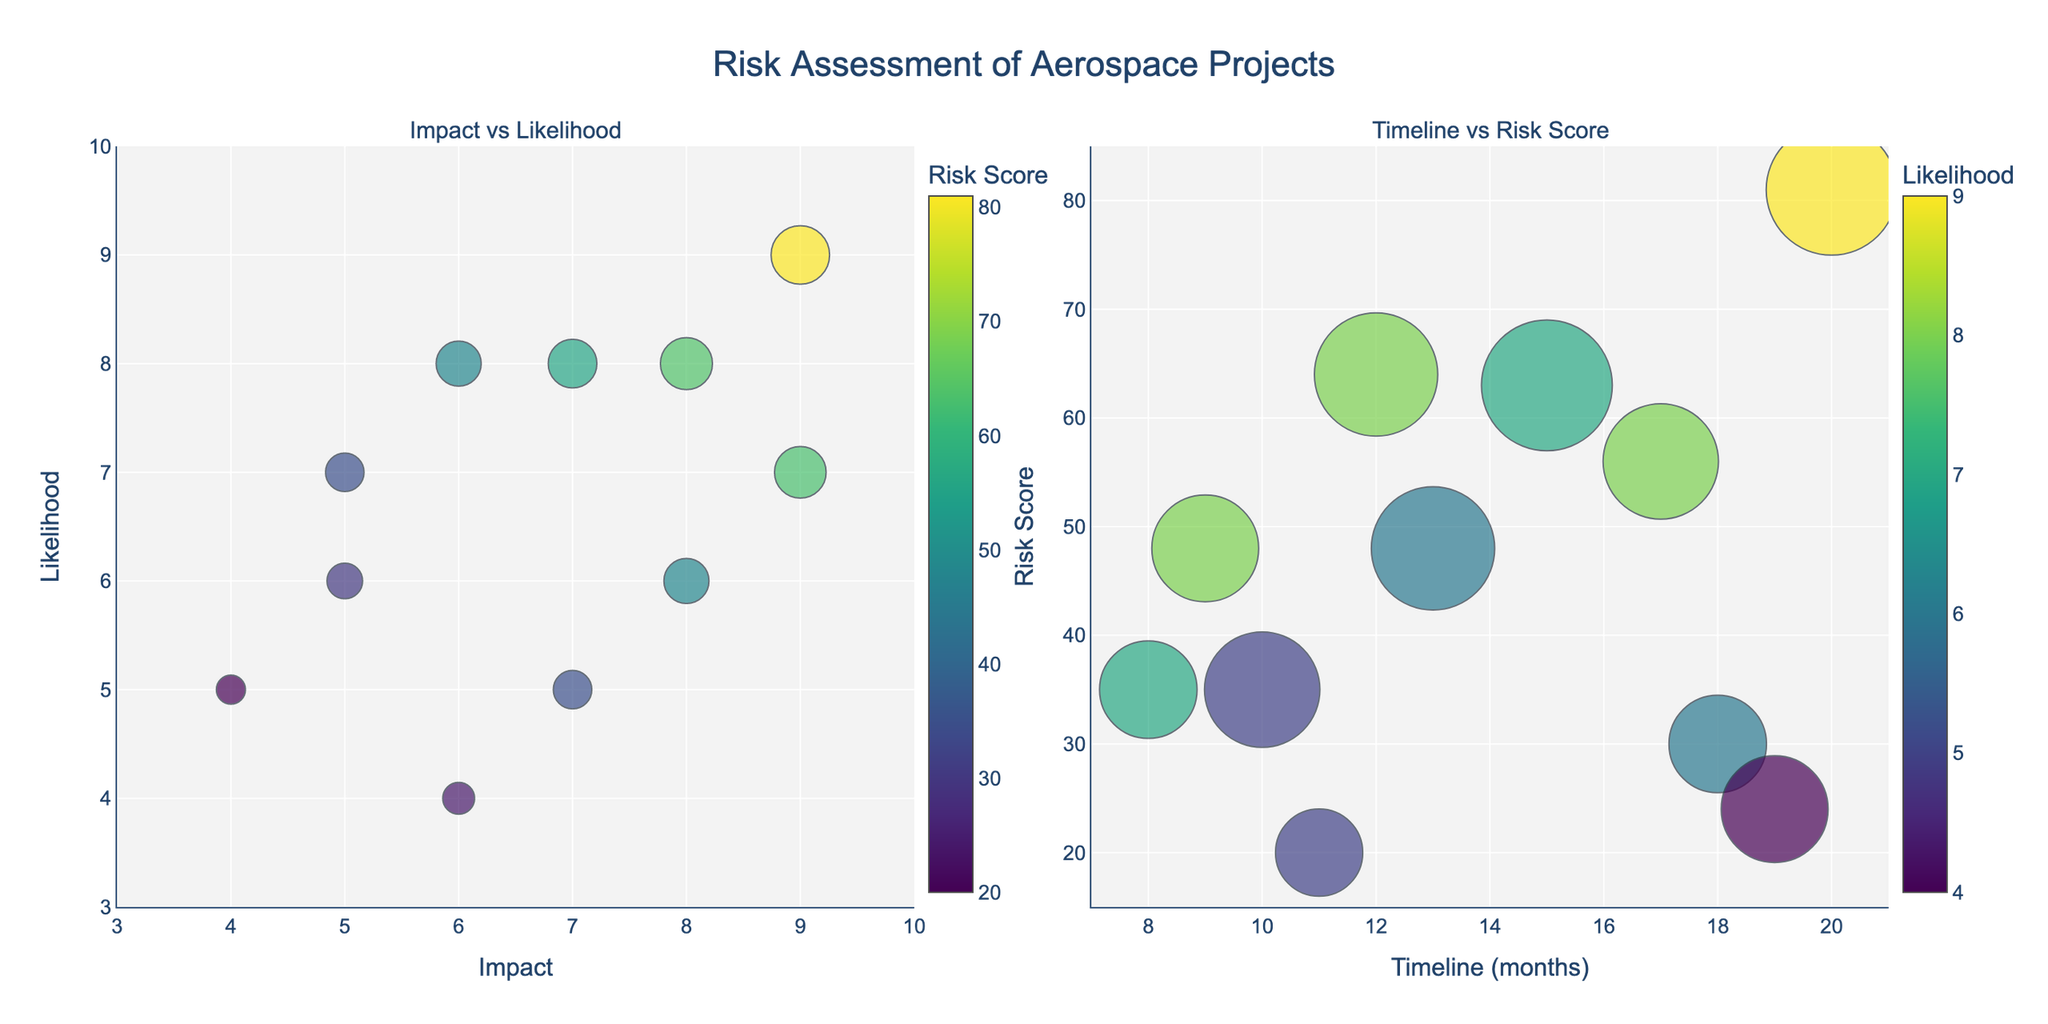What is the title of the figure? The title of the figure is located at the top and is often the most prominent text. It provides a summary of what the figure represents.
Answer: Risk Assessment of Aerospace Projects Which project has the highest Risk Score in the 'Impact vs Likelihood' subplot? Look for the largest bubble in the 'Impact vs Likelihood' subplot. The bubble for Project Alcubierre is the biggest, indicating the highest Risk Score.
Answer: Project Alcubierre In the 'Timeline vs Risk Score' subplot, what is the timeline range shown on the x-axis? Check the x-axis labels in the 'Timeline vs Risk Score' plot to identify the minimum and maximum values.
Answer: 7 to 21 months What projects have the highest Impact value? In the 'Impact vs Likelihood' subplot, locate the bubbles at the extreme right of the x-axis which represents the highest impact values. Projects Orion and Alcubierre each have an impact value of 9.
Answer: Project Orion and Project Alcubierre How many projects have a likelihood value of 8 in the 'Impact vs Likelihood' subplot? Check for the bubbles that align with the y-axis value of 8. Projects Falcon, Helios, and Cassini each have a likelihood value of 8. Count these projects.
Answer: 3 projects Which project is represented by the largest bubble in the 'Timeline vs Risk Score' subplot, and what is its Impact and Risk Score? In the 'Timeline vs Risk Score' subplot, identify the largest bubble based on size. Hovering over or checking the largest bubble reveals it is Project Alcubierre, with an Impact of 9 and Risk Score of 81.
Answer: Project Alcubierre, Impact 9, Risk Score 81 How does the Risk Score of Project Prometheus compare to that of Project Pegasus? Locate the bubbles for Project Prometheus and Project Pegasus in the 'Impact vs Likelihood' subplot to compare their sizes visually. Both have similar bubble sizes, but Project Pegasus has a Risk Score of 35, which matches that of Project Prometheus.
Answer: Equal Which project has the shortest timeline, and what is its Risk Score? In the 'Timeline vs Risk Score' subplot, find the bubble closest to the left end of the x-axis, representing the shortest timeline. Project Prometheus has a timeline of 8 months and a Risk Score of 35.
Answer: Project Prometheus, Risk Score 35 What general trend can be observed between Impact and Likelihood in relation to Risk Score? Observe the distribution of bubble sizes in the 'Impact vs Likelihood' subplot. Generally, larger bubbles (indicating higher Risk Scores) are concentrated where both Impact and Likelihood values are higher.
Answer: Higher Impact and Likelihood tend to associate with higher Risk Scores 